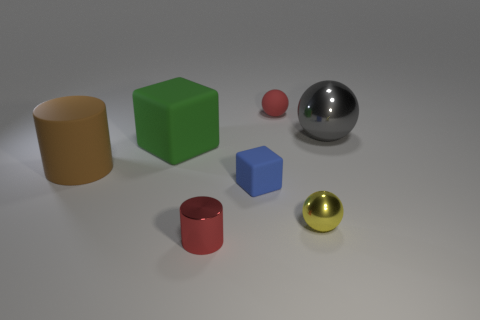What shape is the small red thing left of the red thing behind the object on the left side of the big green block?
Keep it short and to the point. Cylinder. There is a block behind the blue block; is it the same size as the sphere in front of the large metal thing?
Provide a succinct answer. No. How many tiny cylinders are the same material as the tiny yellow object?
Your answer should be compact. 1. There is a tiny sphere that is behind the metal ball that is behind the large matte cylinder; how many small yellow metal things are behind it?
Your answer should be compact. 0. Is the gray shiny thing the same shape as the yellow metal object?
Give a very brief answer. Yes. Is there a red matte thing of the same shape as the tiny yellow object?
Ensure brevity in your answer.  Yes. The blue thing that is the same size as the yellow metal sphere is what shape?
Make the answer very short. Cube. What material is the cylinder behind the red thing that is in front of the large thing behind the large green rubber cube?
Your answer should be compact. Rubber. Does the yellow sphere have the same size as the red matte thing?
Your response must be concise. Yes. What material is the big gray sphere?
Give a very brief answer. Metal. 